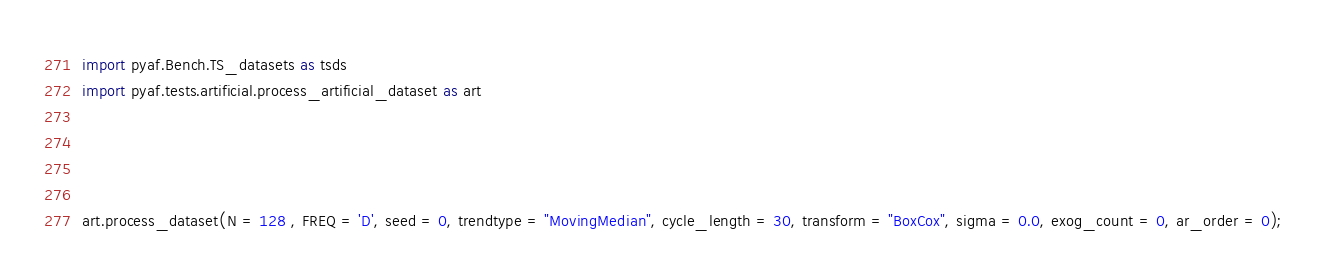Convert code to text. <code><loc_0><loc_0><loc_500><loc_500><_Python_>import pyaf.Bench.TS_datasets as tsds
import pyaf.tests.artificial.process_artificial_dataset as art




art.process_dataset(N = 128 , FREQ = 'D', seed = 0, trendtype = "MovingMedian", cycle_length = 30, transform = "BoxCox", sigma = 0.0, exog_count = 0, ar_order = 0);</code> 